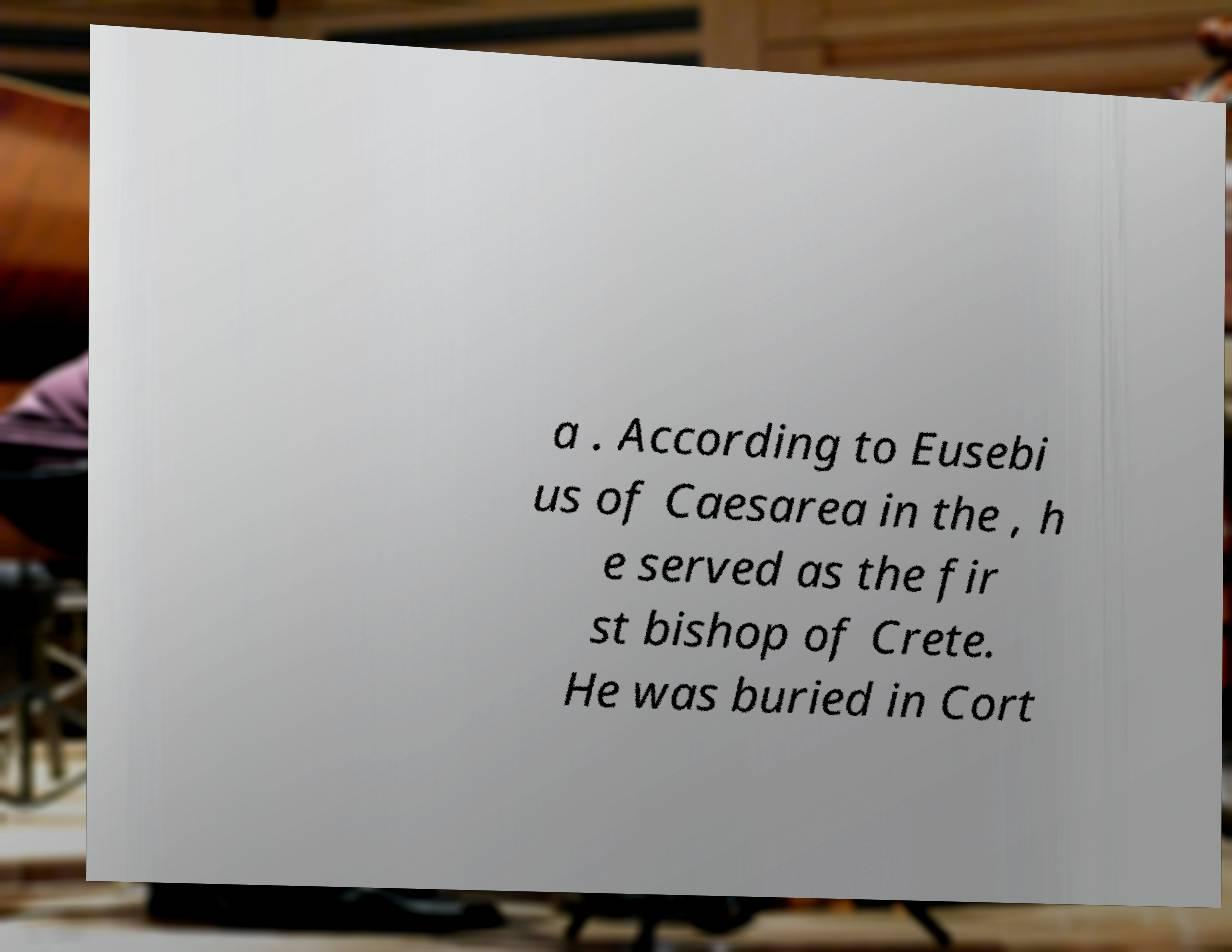I need the written content from this picture converted into text. Can you do that? a . According to Eusebi us of Caesarea in the , h e served as the fir st bishop of Crete. He was buried in Cort 